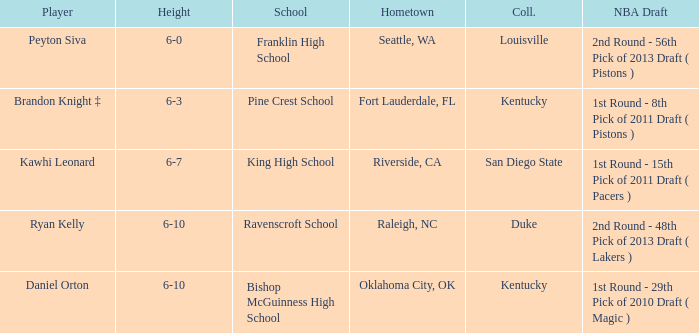Which school is in Raleigh, NC? Ravenscroft School. 